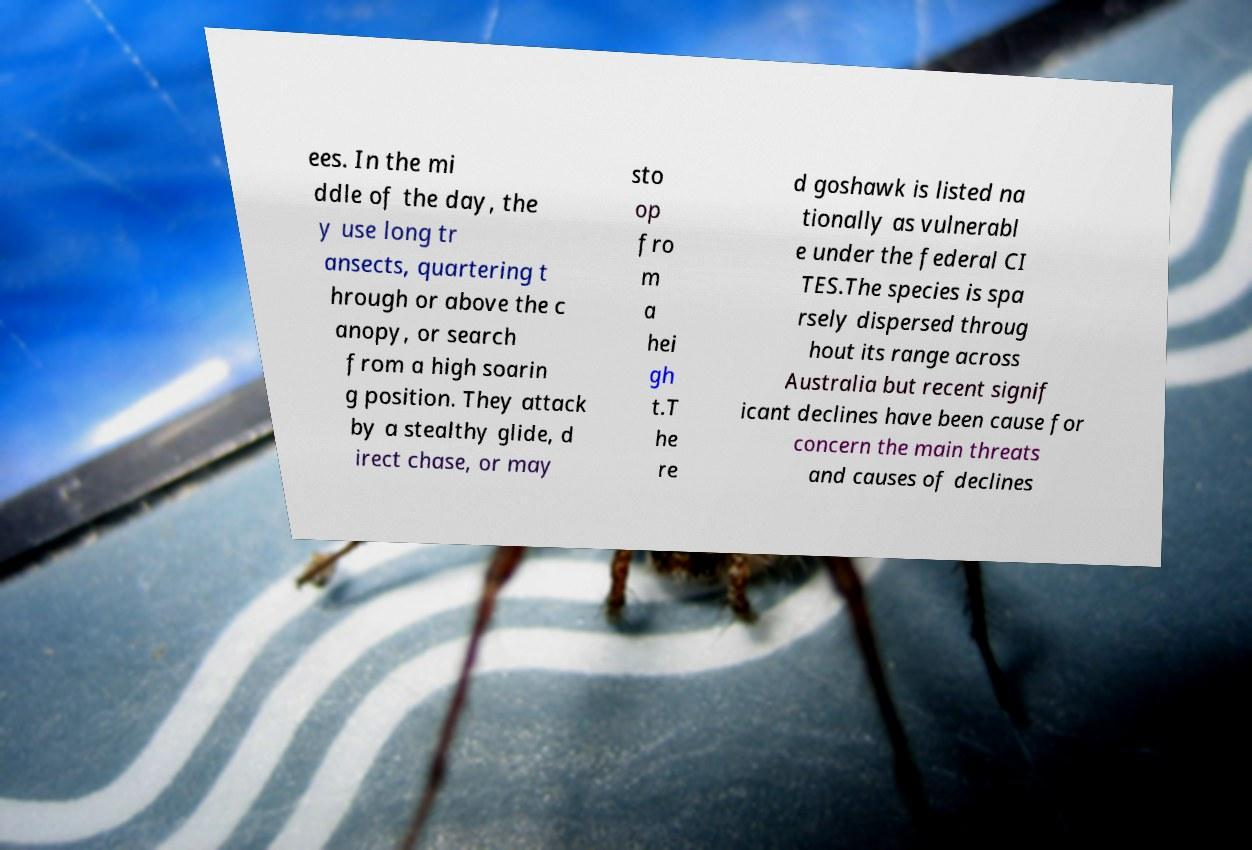Could you extract and type out the text from this image? ees. In the mi ddle of the day, the y use long tr ansects, quartering t hrough or above the c anopy, or search from a high soarin g position. They attack by a stealthy glide, d irect chase, or may sto op fro m a hei gh t.T he re d goshawk is listed na tionally as vulnerabl e under the federal CI TES.The species is spa rsely dispersed throug hout its range across Australia but recent signif icant declines have been cause for concern the main threats and causes of declines 